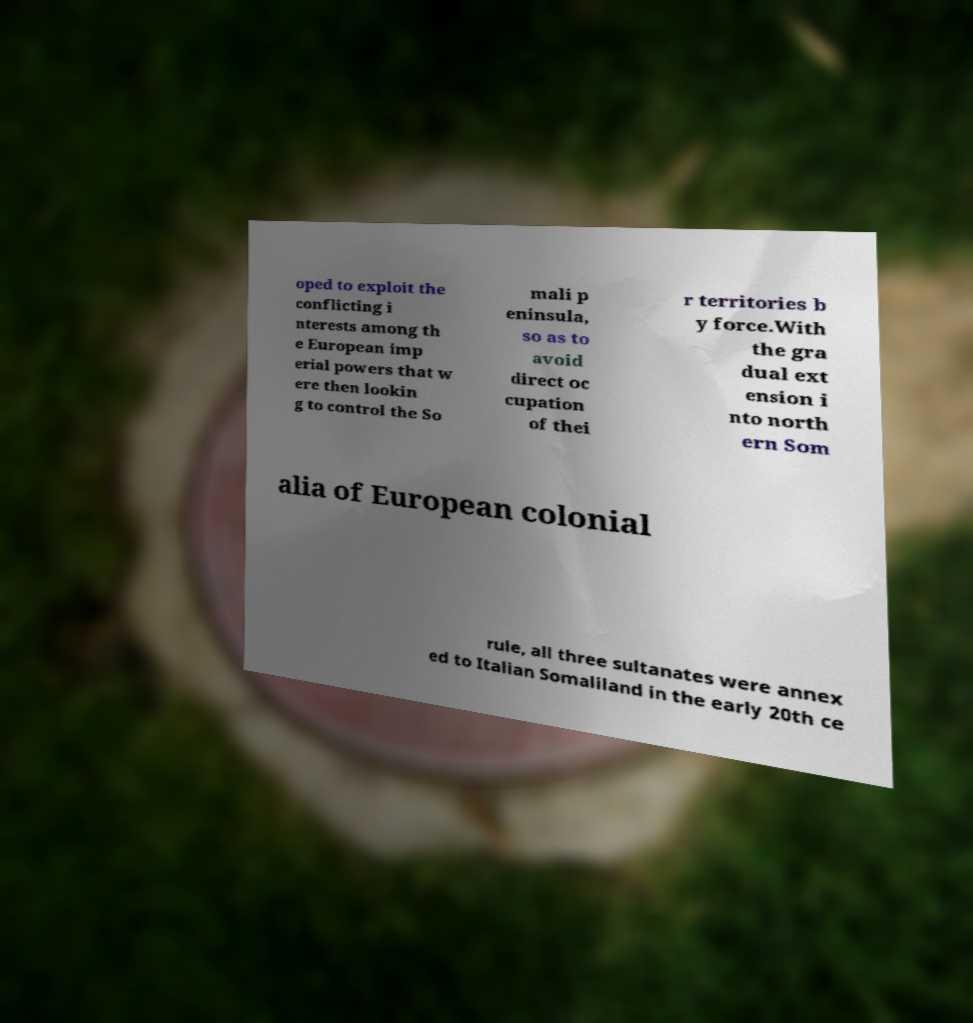Can you read and provide the text displayed in the image?This photo seems to have some interesting text. Can you extract and type it out for me? oped to exploit the conflicting i nterests among th e European imp erial powers that w ere then lookin g to control the So mali p eninsula, so as to avoid direct oc cupation of thei r territories b y force.With the gra dual ext ension i nto north ern Som alia of European colonial rule, all three sultanates were annex ed to Italian Somaliland in the early 20th ce 